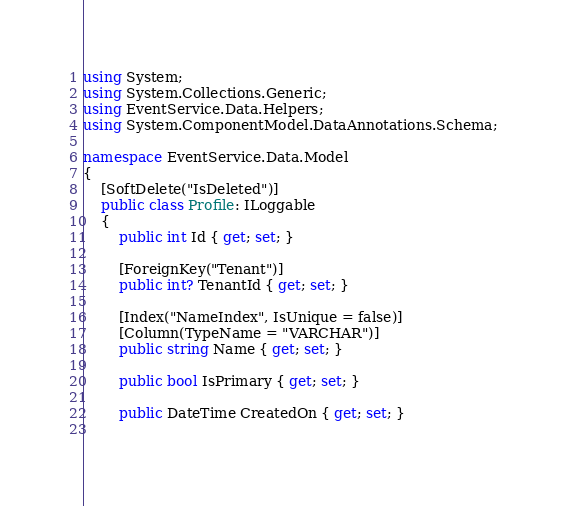Convert code to text. <code><loc_0><loc_0><loc_500><loc_500><_C#_>using System;
using System.Collections.Generic;
using EventService.Data.Helpers;
using System.ComponentModel.DataAnnotations.Schema;

namespace EventService.Data.Model
{
    [SoftDelete("IsDeleted")]
    public class Profile: ILoggable
    {
        public int Id { get; set; }
        
		[ForeignKey("Tenant")]
        public int? TenantId { get; set; }
        
		[Index("NameIndex", IsUnique = false)]
        [Column(TypeName = "VARCHAR")]        
		public string Name { get; set; }

        public bool IsPrimary { get; set; }
        
		public DateTime CreatedOn { get; set; }
        </code> 